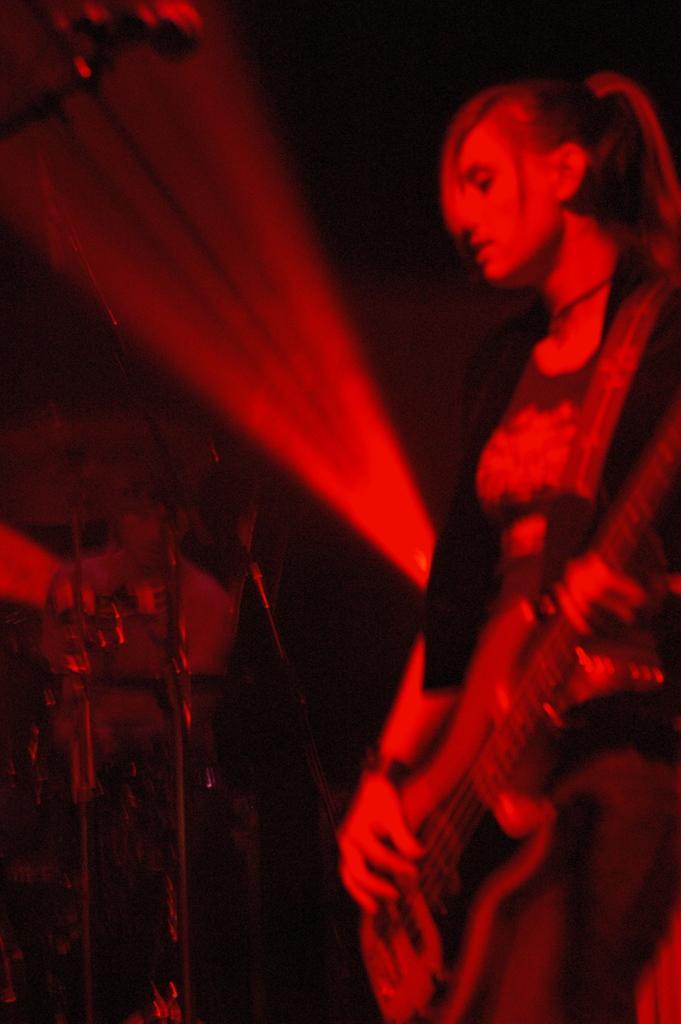Can you describe this image briefly? A woman is holding a guitar and playing. In the background there is a person and a drums. And the image is looking red and black. 